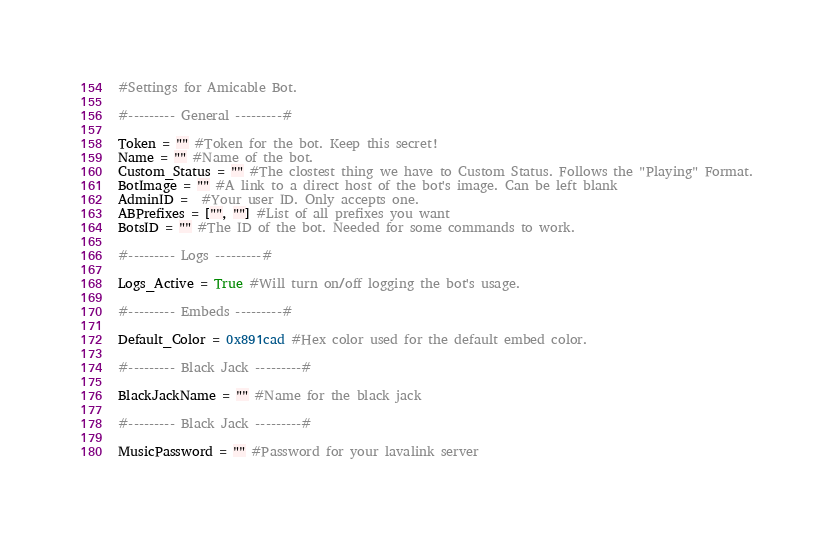<code> <loc_0><loc_0><loc_500><loc_500><_Python_>#Settings for Amicable Bot.

#--------- General ---------#

Token = "" #Token for the bot. Keep this secret!
Name = "" #Name of the bot.
Custom_Status = "" #The clostest thing we have to Custom Status. Follows the "Playing" Format.
BotImage = "" #A link to a direct host of the bot's image. Can be left blank
AdminID =  #Your user ID. Only accepts one.
ABPrefixes = ["", ""] #List of all prefixes you want
BotsID = "" #The ID of the bot. Needed for some commands to work.

#--------- Logs ---------#

Logs_Active = True #Will turn on/off logging the bot's usage.

#--------- Embeds ---------#

Default_Color = 0x891cad #Hex color used for the default embed color.

#--------- Black Jack ---------#

BlackJackName = "" #Name for the black jack

#--------- Black Jack ---------#

MusicPassword = "" #Password for your lavalink server</code> 